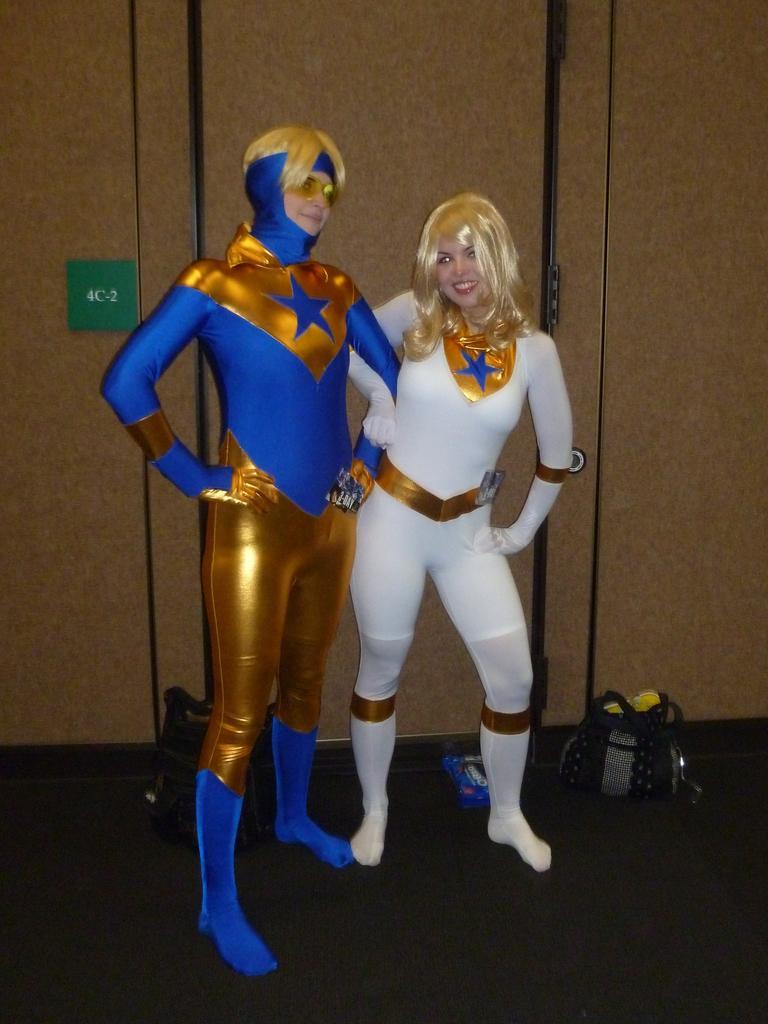How would you summarize this image in a sentence or two? In this image we can see two persons with costume. In the back there is a wall. Also there are bags on the floor. 